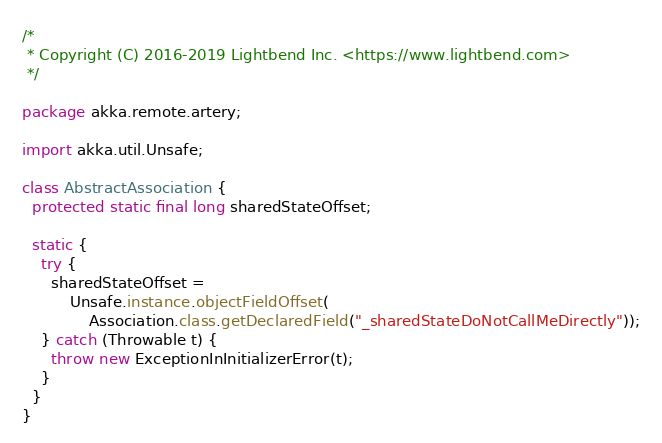<code> <loc_0><loc_0><loc_500><loc_500><_Java_>/*
 * Copyright (C) 2016-2019 Lightbend Inc. <https://www.lightbend.com>
 */

package akka.remote.artery;

import akka.util.Unsafe;

class AbstractAssociation {
  protected static final long sharedStateOffset;

  static {
    try {
      sharedStateOffset =
          Unsafe.instance.objectFieldOffset(
              Association.class.getDeclaredField("_sharedStateDoNotCallMeDirectly"));
    } catch (Throwable t) {
      throw new ExceptionInInitializerError(t);
    }
  }
}
</code> 